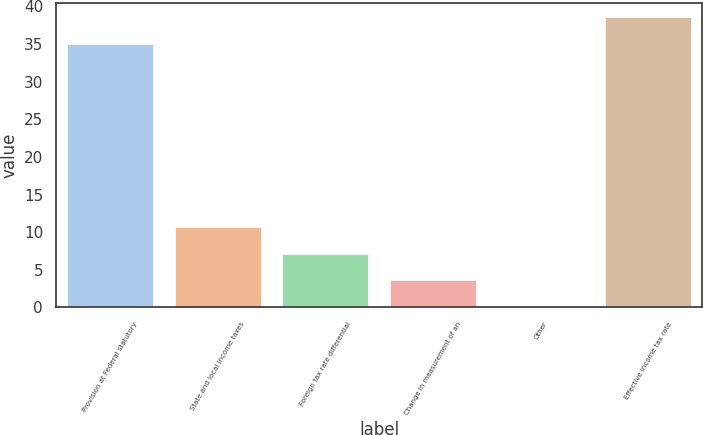Convert chart to OTSL. <chart><loc_0><loc_0><loc_500><loc_500><bar_chart><fcel>Provision at Federal statutory<fcel>State and local income taxes<fcel>Foreign tax rate differential<fcel>Change in measurement of an<fcel>Other<fcel>Effective income tax rate<nl><fcel>35<fcel>10.66<fcel>7.14<fcel>3.62<fcel>0.1<fcel>38.52<nl></chart> 